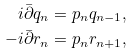Convert formula to latex. <formula><loc_0><loc_0><loc_500><loc_500>i \bar { \partial } q _ { n } = p _ { n } q _ { n - 1 } , \\ - i \bar { \partial } r _ { n } = p _ { n } r _ { n + 1 } ,</formula> 